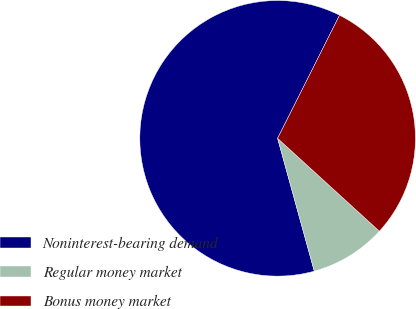Convert chart. <chart><loc_0><loc_0><loc_500><loc_500><pie_chart><fcel>Noninterest-bearing demand<fcel>Regular money market<fcel>Bonus money market<nl><fcel>61.71%<fcel>8.94%<fcel>29.35%<nl></chart> 